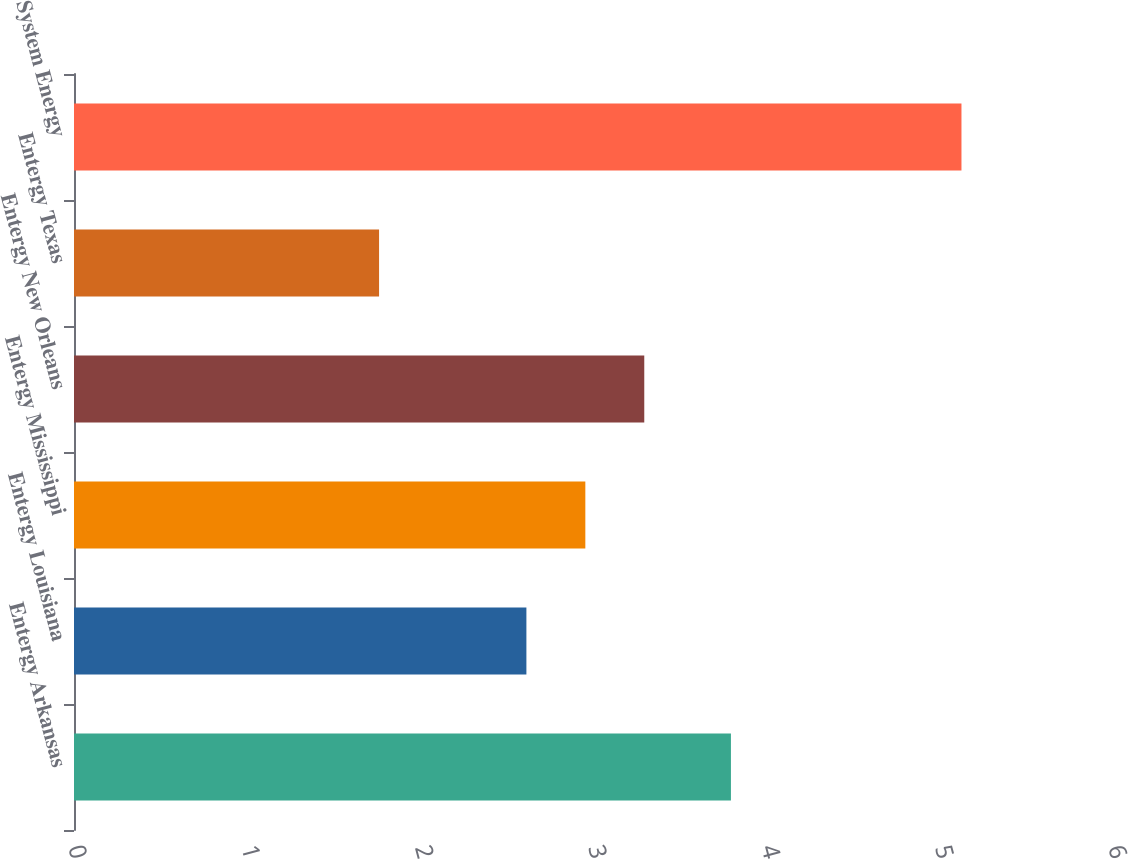<chart> <loc_0><loc_0><loc_500><loc_500><bar_chart><fcel>Entergy Arkansas<fcel>Entergy Louisiana<fcel>Entergy Mississippi<fcel>Entergy New Orleans<fcel>Entergy Texas<fcel>System Energy<nl><fcel>3.79<fcel>2.61<fcel>2.95<fcel>3.29<fcel>1.76<fcel>5.12<nl></chart> 